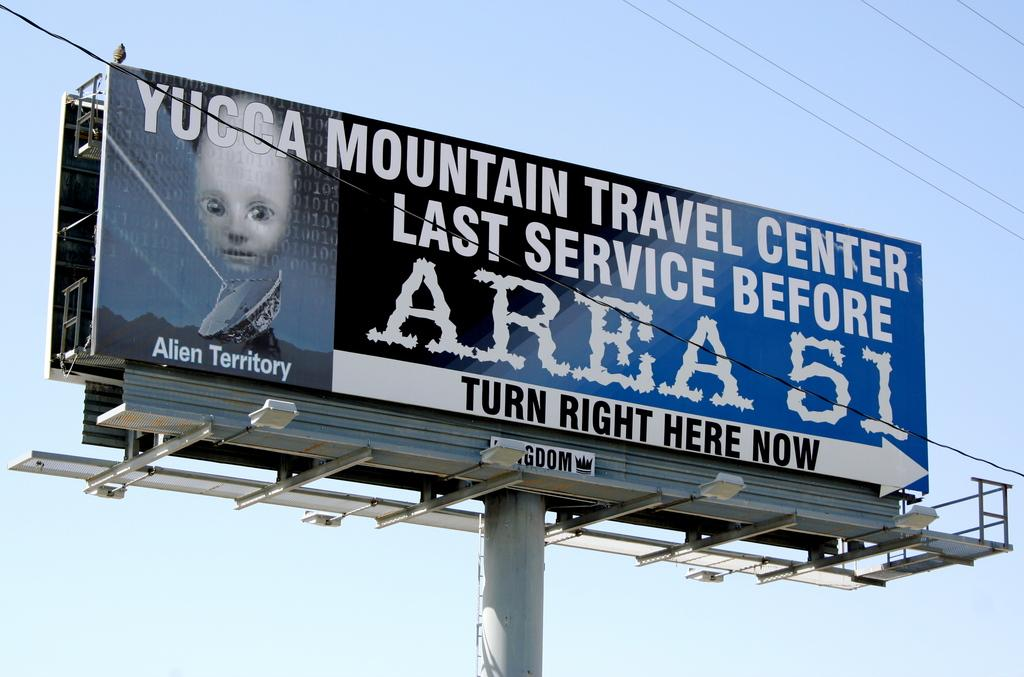<image>
Present a compact description of the photo's key features. A large billboard with the text turn right here now for area 51. 